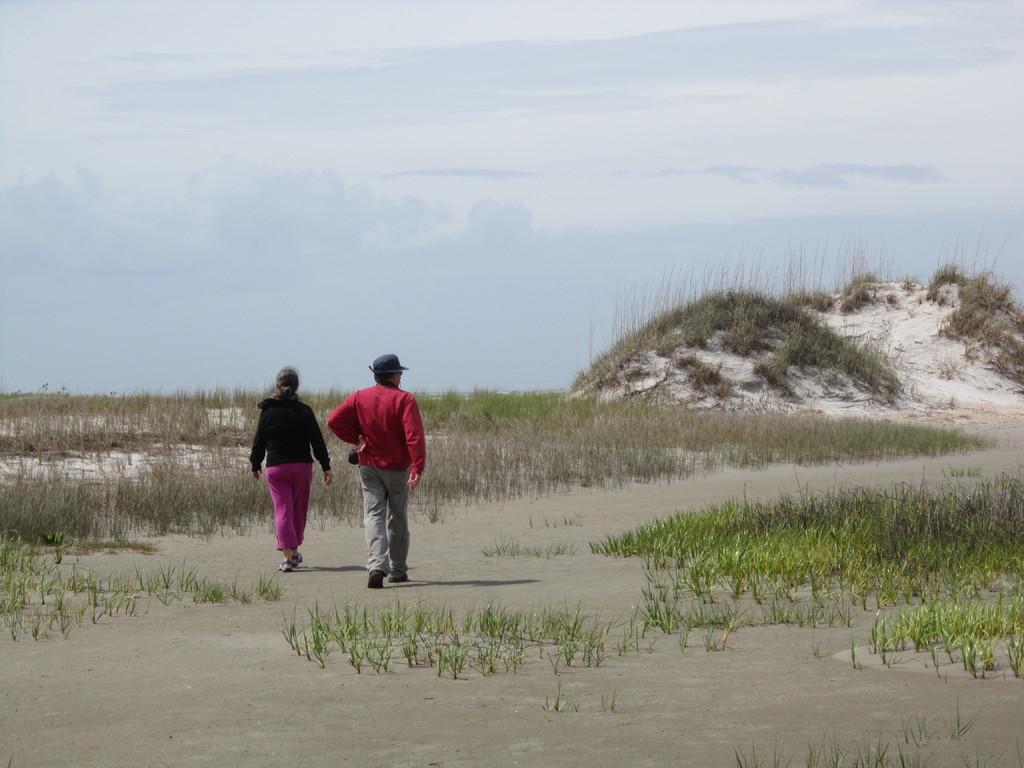In one or two sentences, can you explain what this image depicts? In the foreground of this image, there is a man and a woman walking on the sand. We can also see the grass on either side to the path. In the background, there is grass, and, sky and the cloud. 